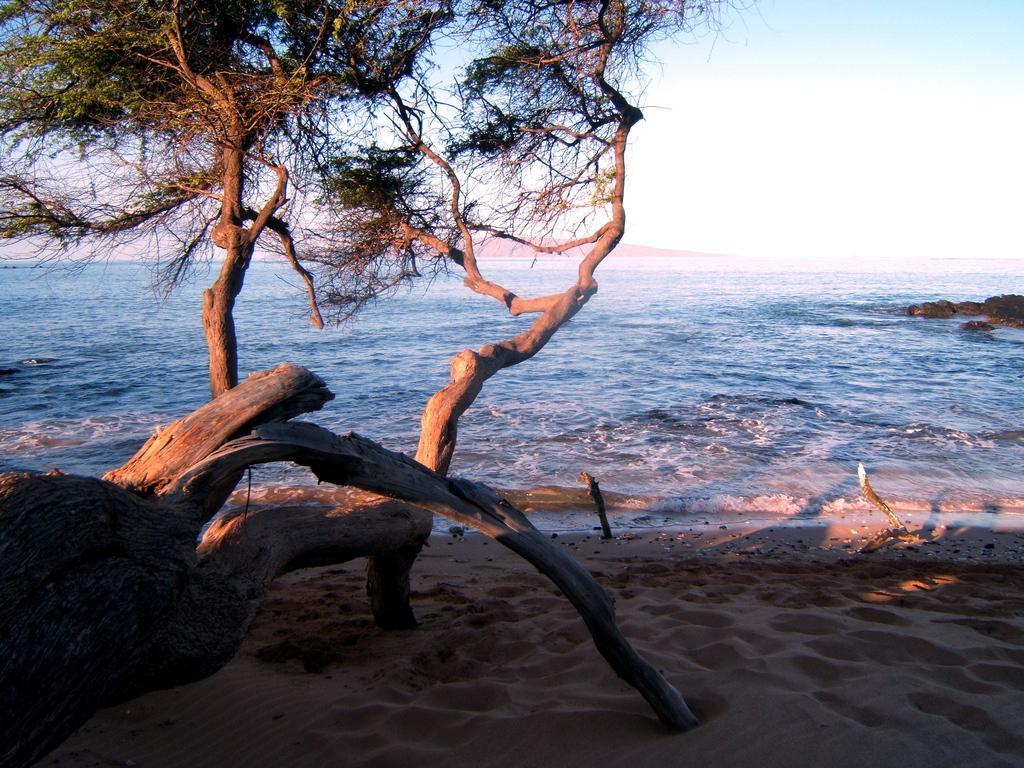Describe this image in one or two sentences. There are trees and this is sand. Here we can see water. In the background there is sky. 